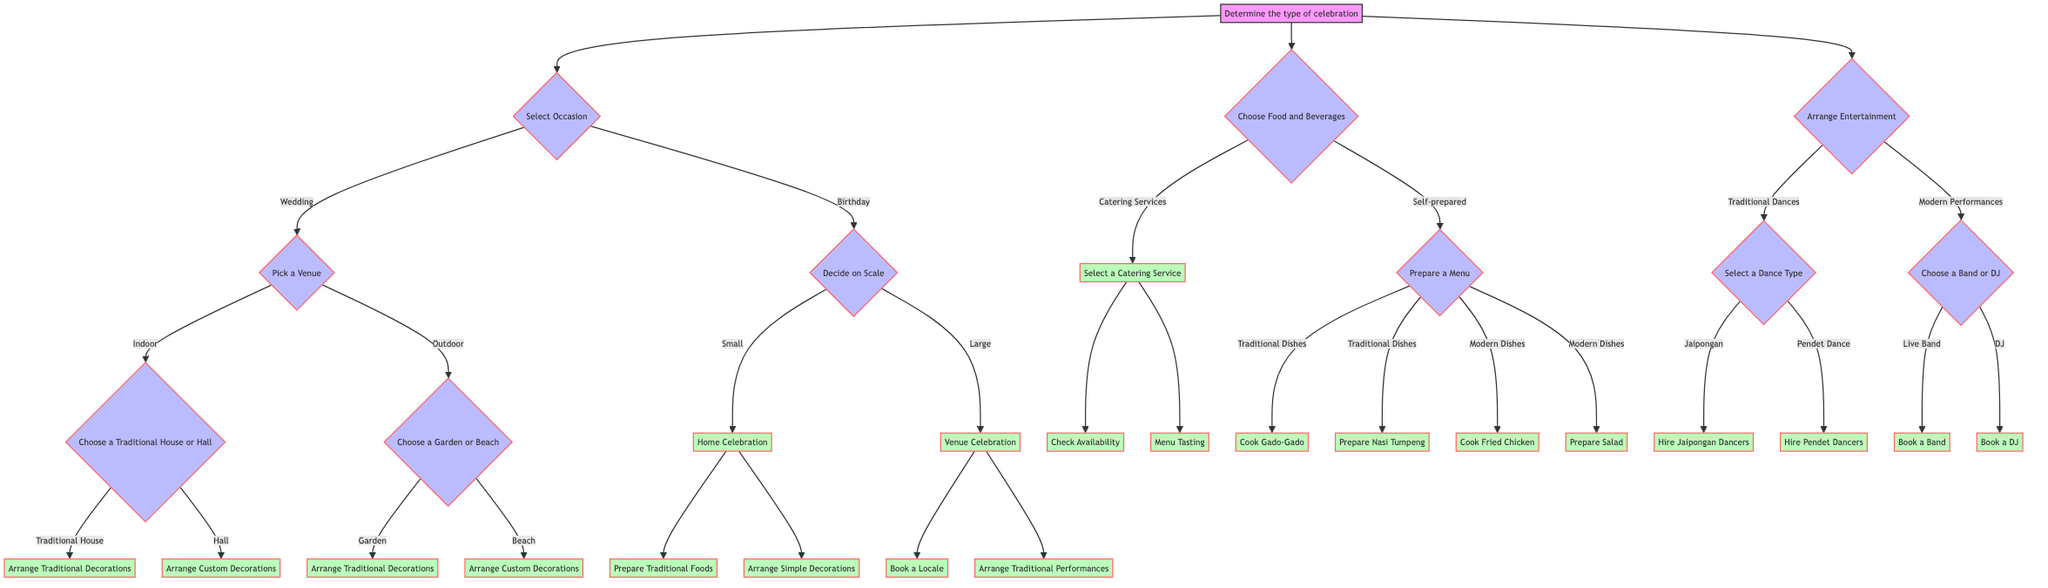What is the first step in planning the celebration? The diagram starts with the step "Determine the type of celebration." This is the initial action before proceeding to any options.
Answer: Determine the type of celebration How many choices are there under "Select Occasion"? The "Select Occasion" node provides two clear choices: "Wedding" and "Birthday." Thus, there are two choices.
Answer: 2 What happens if you choose "Outdoor" under "Pick a Venue"? Choosing "Outdoor" leads to the step "Choose a Garden or Beach," which then branches out to two further options: "Garden" and "Beach."
Answer: Choose a Garden or Beach If a celebration is categorized as "Large" for a birthday, which actions are required? Once "Large" is selected under "Decide on Scale," the next actions to take are "Book a Locale" and "Arrange Traditional Performances."
Answer: Book a Locale, Arrange Traditional Performances What type of decorations are arranged for a "Traditional House"? When choosing a "Traditional House" under the "Choose a Traditional House or Hall" node, the action specified is to "Arrange Traditional Decorations."
Answer: Arrange Traditional Decorations Which section follows "Choose Food and Beverages"? After making a selection in the "Choose Food and Beverages" node, it branches out to “Catering Services” or “Self-prepared.” This is crucial for the next steps in the planning process.
Answer: Catering Services or Self-prepared What are the two options for entertainment choices? The diagram denotes two main types of entertainment under "Arrange Entertainment": "Traditional Dances" and "Modern Performances." Therefore, there are two entertainment choices.
Answer: Traditional Dances, Modern Performances What must be done after selecting "Catering Services"? Choosing "Catering Services" leads to the next step "Select a Catering Service," followed by actions like "Check Availability" and "Menu Tasting."
Answer: Select a Catering Service Which option allows for the preparation of modern dishes? The "Self-prepared" option under "Choose Food and Beverages" leads to a choice for "Modern Dishes," allowing for preparation such as "Cook Fried Chicken" and "Prepare Salad."
Answer: Modern Dishes 